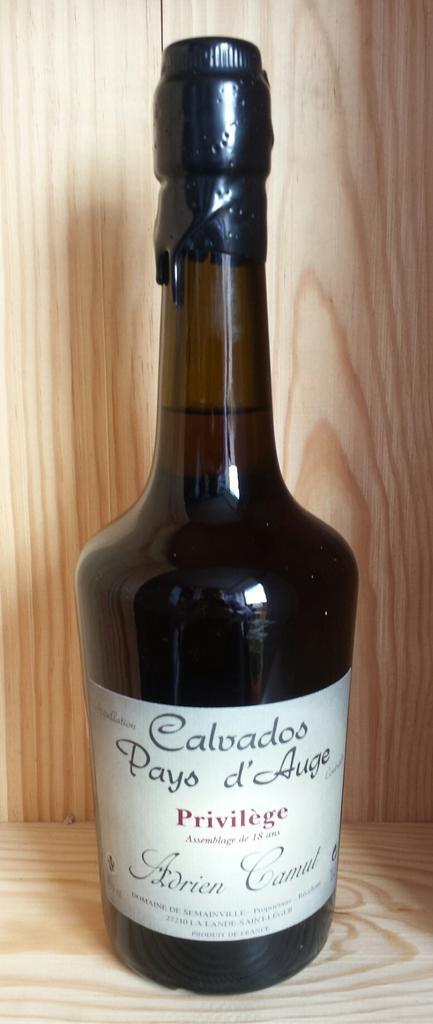How would you summarize this image in a sentence or two? In this image we can see a wine bottle which is kept on this wooden table. 